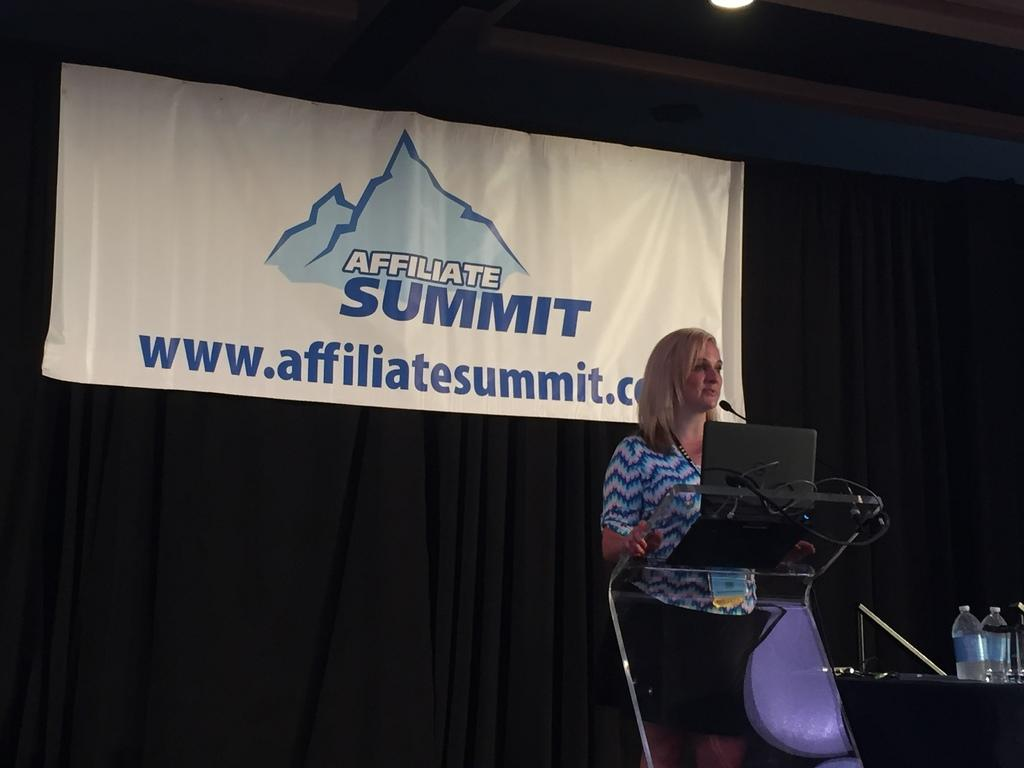Provide a one-sentence caption for the provided image. A blonde woman stands at a pedetal speaking in front of a banner proclaiming an Affiliate Summit. 